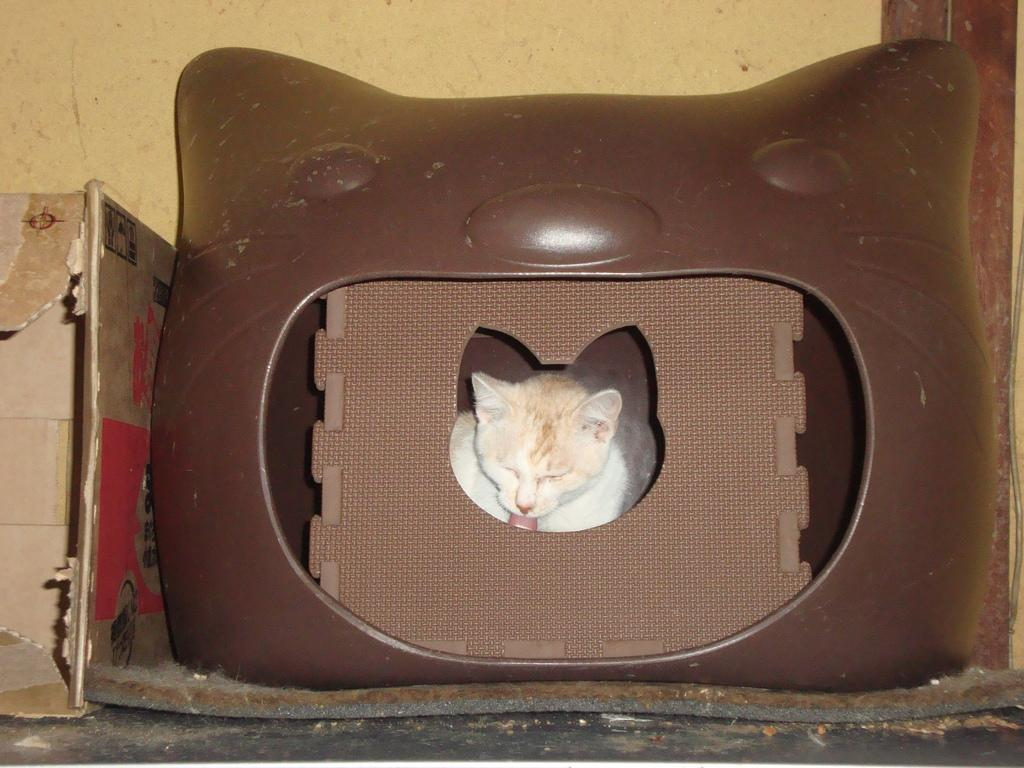What animal is present in the image? There is a cat in the image. Where is the cat located? The cat is inside a box. What is the position of the box in the image? The box is placed on the ground. What can be seen in the background of the image? There is a cardboard box in the background of the image. What size is the team that the cat is a part of in the image? There is no team present in the image, and the cat's size is not mentioned in the facts provided. 